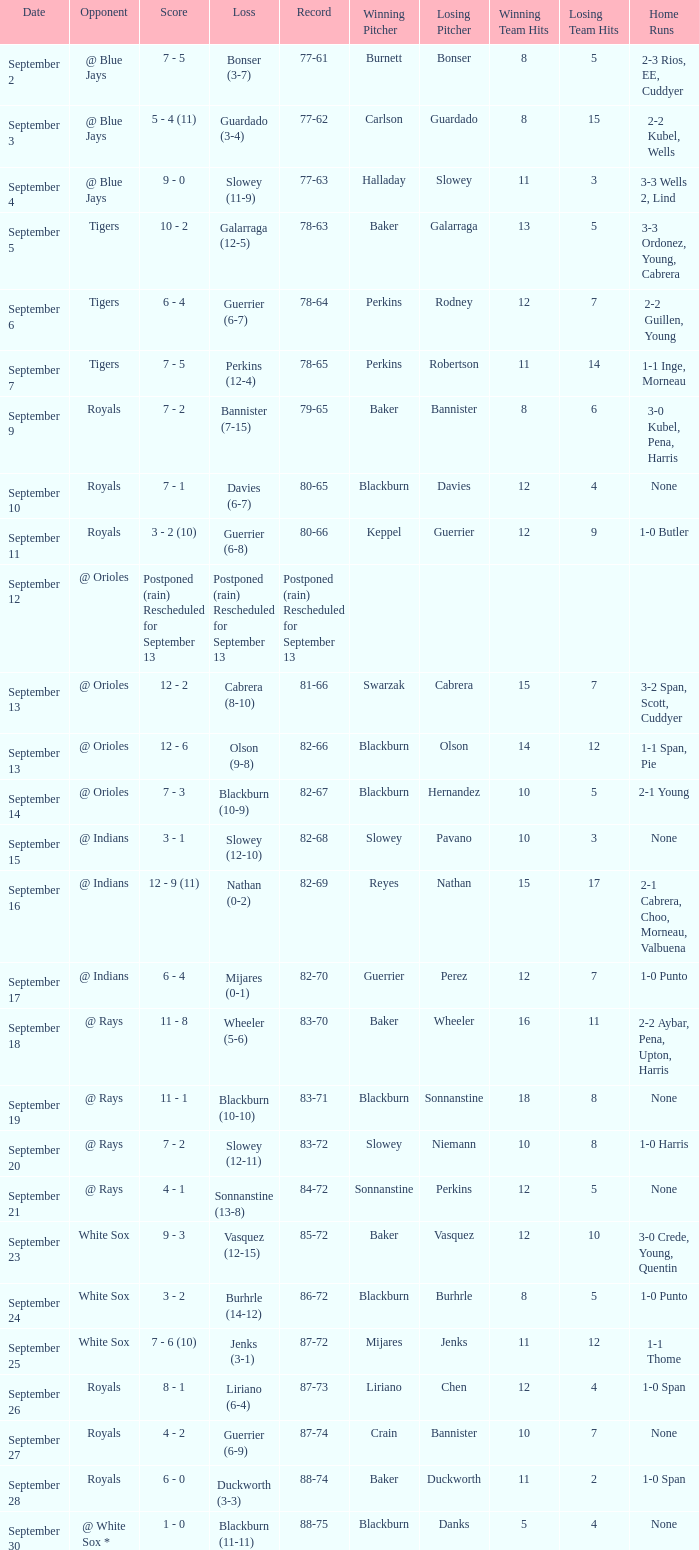What score has the opponent of tigers and a record of 78-64? 6 - 4. I'm looking to parse the entire table for insights. Could you assist me with that? {'header': ['Date', 'Opponent', 'Score', 'Loss', 'Record', 'Winning Pitcher', 'Losing Pitcher', 'Winning Team Hits', 'Losing Team Hits', 'Home Runs'], 'rows': [['September 2', '@ Blue Jays', '7 - 5', 'Bonser (3-7)', '77-61', 'Burnett', 'Bonser', '8', '5', '2-3 Rios, EE, Cuddyer'], ['September 3', '@ Blue Jays', '5 - 4 (11)', 'Guardado (3-4)', '77-62', 'Carlson', 'Guardado', '8', '15', '2-2 Kubel, Wells'], ['September 4', '@ Blue Jays', '9 - 0', 'Slowey (11-9)', '77-63', 'Halladay', 'Slowey', '11', '3', '3-3 Wells 2, Lind'], ['September 5', 'Tigers', '10 - 2', 'Galarraga (12-5)', '78-63', 'Baker', 'Galarraga', '13', '5', '3-3 Ordonez, Young, Cabrera'], ['September 6', 'Tigers', '6 - 4', 'Guerrier (6-7)', '78-64', 'Perkins', 'Rodney', '12', '7', '2-2 Guillen, Young'], ['September 7', 'Tigers', '7 - 5', 'Perkins (12-4)', '78-65', 'Perkins', 'Robertson', '11', '14', '1-1 Inge, Morneau'], ['September 9', 'Royals', '7 - 2', 'Bannister (7-15)', '79-65', 'Baker', 'Bannister', '8', '6', '3-0 Kubel, Pena, Harris'], ['September 10', 'Royals', '7 - 1', 'Davies (6-7)', '80-65', 'Blackburn', 'Davies', '12', '4', 'None'], ['September 11', 'Royals', '3 - 2 (10)', 'Guerrier (6-8)', '80-66', 'Keppel', 'Guerrier', '12', '9', '1-0 Butler'], ['September 12', '@ Orioles', 'Postponed (rain) Rescheduled for September 13', 'Postponed (rain) Rescheduled for September 13', 'Postponed (rain) Rescheduled for September 13', '', '', '', '', ''], ['September 13', '@ Orioles', '12 - 2', 'Cabrera (8-10)', '81-66', 'Swarzak', 'Cabrera', '15', '7', '3-2 Span, Scott, Cuddyer'], ['September 13', '@ Orioles', '12 - 6', 'Olson (9-8)', '82-66', 'Blackburn', 'Olson', '14', '12', '1-1 Span, Pie'], ['September 14', '@ Orioles', '7 - 3', 'Blackburn (10-9)', '82-67', 'Blackburn', 'Hernandez', '10', '5', '2-1 Young'], ['September 15', '@ Indians', '3 - 1', 'Slowey (12-10)', '82-68', 'Slowey', 'Pavano', '10', '3', 'None'], ['September 16', '@ Indians', '12 - 9 (11)', 'Nathan (0-2)', '82-69', 'Reyes', 'Nathan', '15', '17', '2-1 Cabrera, Choo, Morneau, Valbuena'], ['September 17', '@ Indians', '6 - 4', 'Mijares (0-1)', '82-70', 'Guerrier', 'Perez', '12', '7', '1-0 Punto'], ['September 18', '@ Rays', '11 - 8', 'Wheeler (5-6)', '83-70', 'Baker', 'Wheeler', '16', '11', '2-2 Aybar, Pena, Upton, Harris'], ['September 19', '@ Rays', '11 - 1', 'Blackburn (10-10)', '83-71', 'Blackburn', 'Sonnanstine', '18', '8', 'None'], ['September 20', '@ Rays', '7 - 2', 'Slowey (12-11)', '83-72', 'Slowey', 'Niemann', '10', '8', '1-0 Harris'], ['September 21', '@ Rays', '4 - 1', 'Sonnanstine (13-8)', '84-72', 'Sonnanstine', 'Perkins', '12', '5', 'None'], ['September 23', 'White Sox', '9 - 3', 'Vasquez (12-15)', '85-72', 'Baker', 'Vasquez', '12', '10', '3-0 Crede, Young, Quentin'], ['September 24', 'White Sox', '3 - 2', 'Burhrle (14-12)', '86-72', 'Blackburn', 'Burhrle', '8', '5', '1-0 Punto'], ['September 25', 'White Sox', '7 - 6 (10)', 'Jenks (3-1)', '87-72', 'Mijares', 'Jenks', '11', '12', '1-1 Thome'], ['September 26', 'Royals', '8 - 1', 'Liriano (6-4)', '87-73', 'Liriano', 'Chen', '12', '4', '1-0 Span'], ['September 27', 'Royals', '4 - 2', 'Guerrier (6-9)', '87-74', 'Crain', 'Bannister', '10', '7', 'None'], ['September 28', 'Royals', '6 - 0', 'Duckworth (3-3)', '88-74', 'Baker', 'Duckworth', '11', '2', '1-0 Span'], ['September 30', '@ White Sox *', '1 - 0', 'Blackburn (11-11)', '88-75', 'Blackburn', 'Danks', '5', '4', 'None']]} 